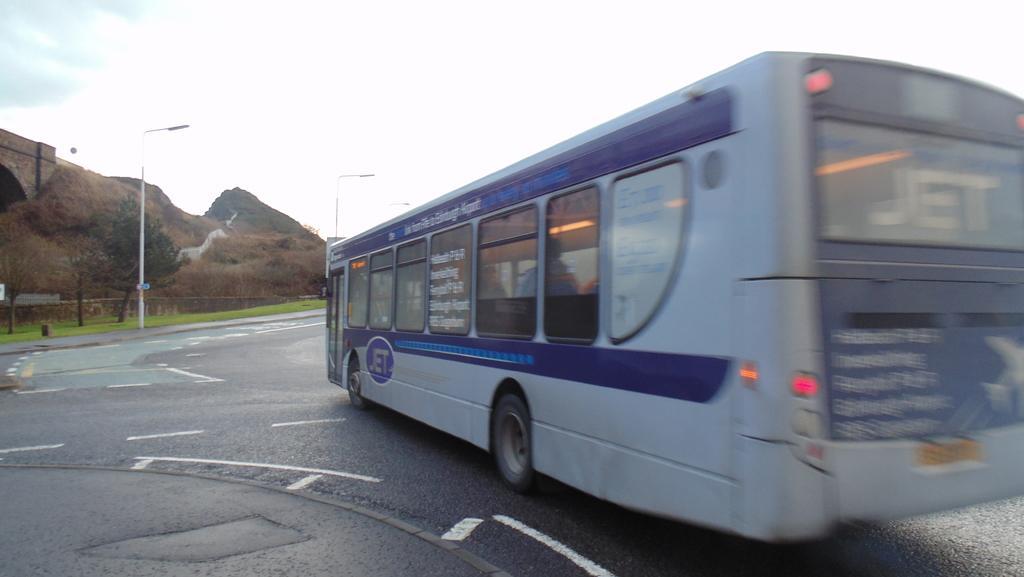Describe this image in one or two sentences. In this image there is a bus on a road, in the background there light poles, trees, mountains and the sky. 